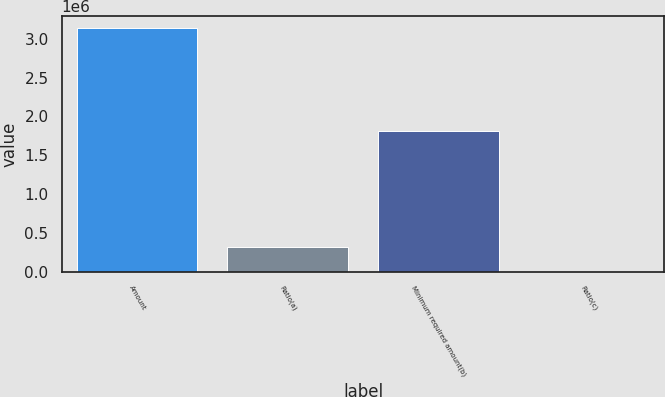<chart> <loc_0><loc_0><loc_500><loc_500><bar_chart><fcel>Amount<fcel>Ratio(a)<fcel>Minimum required amount(b)<fcel>Ratio(c)<nl><fcel>3.13292e+06<fcel>313298<fcel>1.81026e+06<fcel>6.38<nl></chart> 